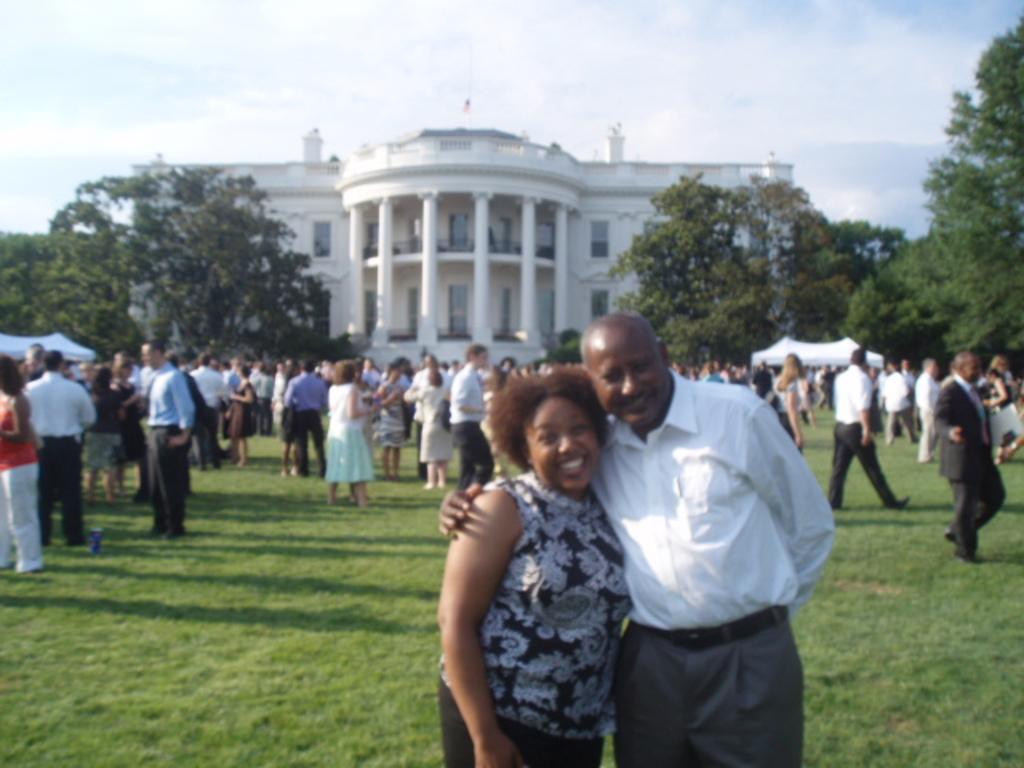Can you describe this image briefly? In this image we can see a crowd standing on the ground. In the background we can see sky with clouds, trees, tents and a building. 